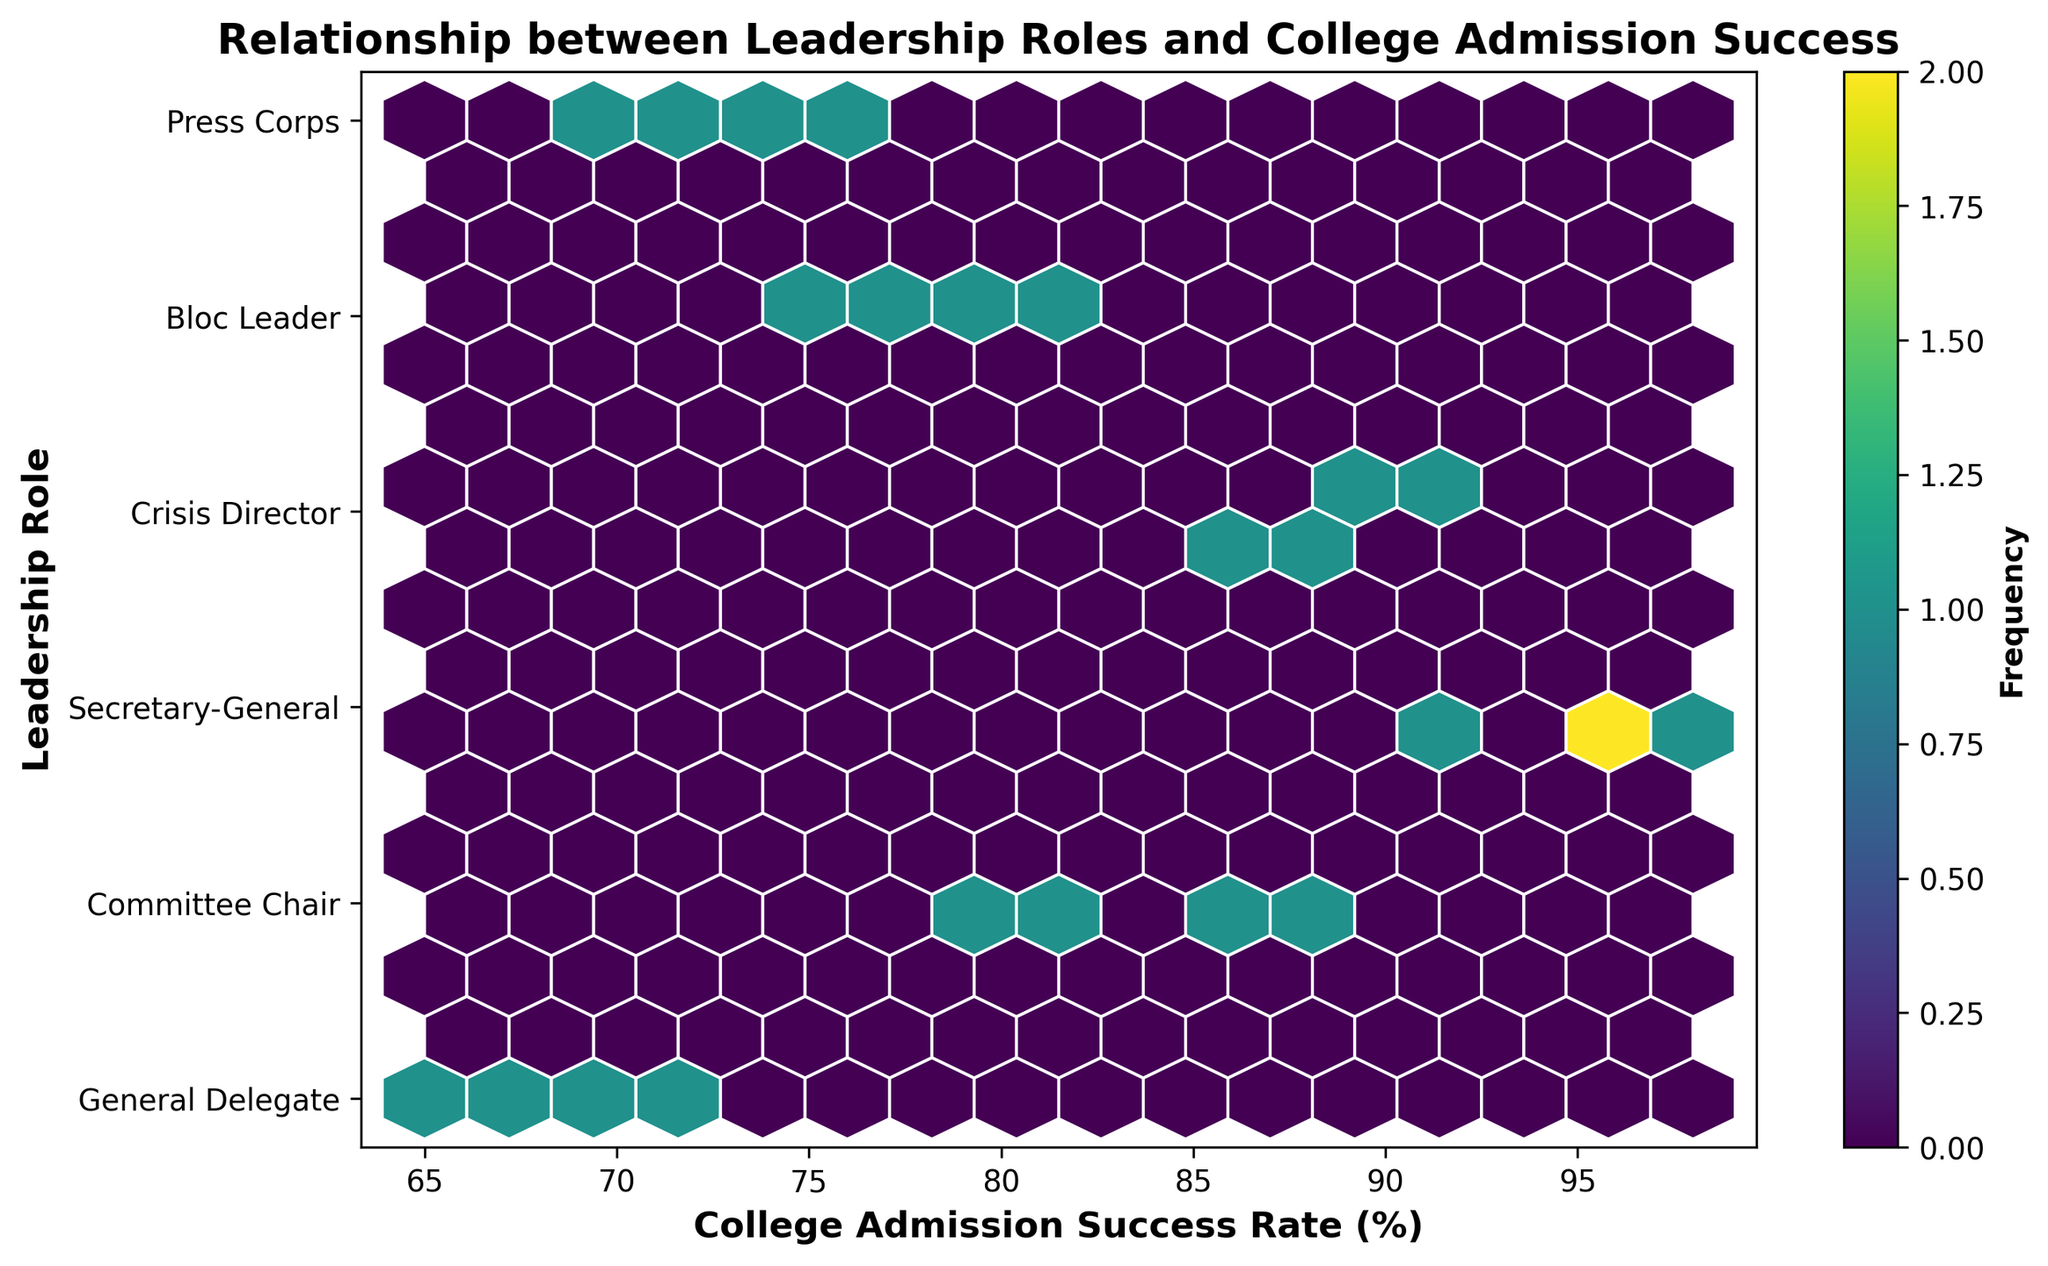What's the title of the plot? The title is displayed at the top of the plot, indicating the main subject being visualized.
Answer: Relationship between Leadership Roles and College Admission Success What do the colors on the hexagons represent? The colors represent the frequency of data points within each hexagon. Based on the color bar, darker hexagons indicate higher frequencies.
Answer: Frequency Which leadership role generally shows the highest college admission success rates? The highest success rates are located on the right side of the plot along the y-tick corresponding to "Secretary-General."
Answer: Secretary-General How are the leadership roles ordered on the y-axis? The y-axis ticks and labels show the order from bottom to top, listing roles in this sequence: General Delegate, Committee Chair, Secretary-General, Crisis Director, Bloc Leader, Press Corps.
Answer: General Delegate, Committee Chair, Secretary-General, Crisis Director, Bloc Leader, Press Corps What can you say about the trend in college admission success rates as the leadership role becomes more prestigious? Observing the hexbin plot, college admission success rates tend to increase as the leadership role becomes more prestigious (moving upward in the y-axis).
Answer: Success rates increase with more prestigious roles Which role has the highest variability in college admission success rates? Variability can be seen through the vertical spread of hexagons for each role. Crisis Director shows a wide spread in success rates between 86% and 92%.
Answer: Crisis Director How does the frequency of data points compare between "General Delegate" and "Crisis Director"? By observing the color intensity and number of hexagons, General Delegate seems to have a higher frequency (darker hexagons) than Crisis Director.
Answer: General Delegate has higher frequency What is the approximate average college admission success rate for "Press Corps"? By averaging visually, the Press Corps role ranges around 70% to 75%. Taking the middle point gives an approximate success rate.
Answer: About 72.5% Are there any roles that overlap in terms of college admission success rates? Yes, some success rates are shared among different roles, such as General Delegate and Press Corps both showing around 70% success rates.
Answer: General Delegate and Press Corps Which leadership role has the most data points clustered close to 80% success rate? By looking at the color intensities and positions, Committee Chair shows many data points close to 80%, indicated by darker hexagons around that rate.
Answer: Committee Chair 